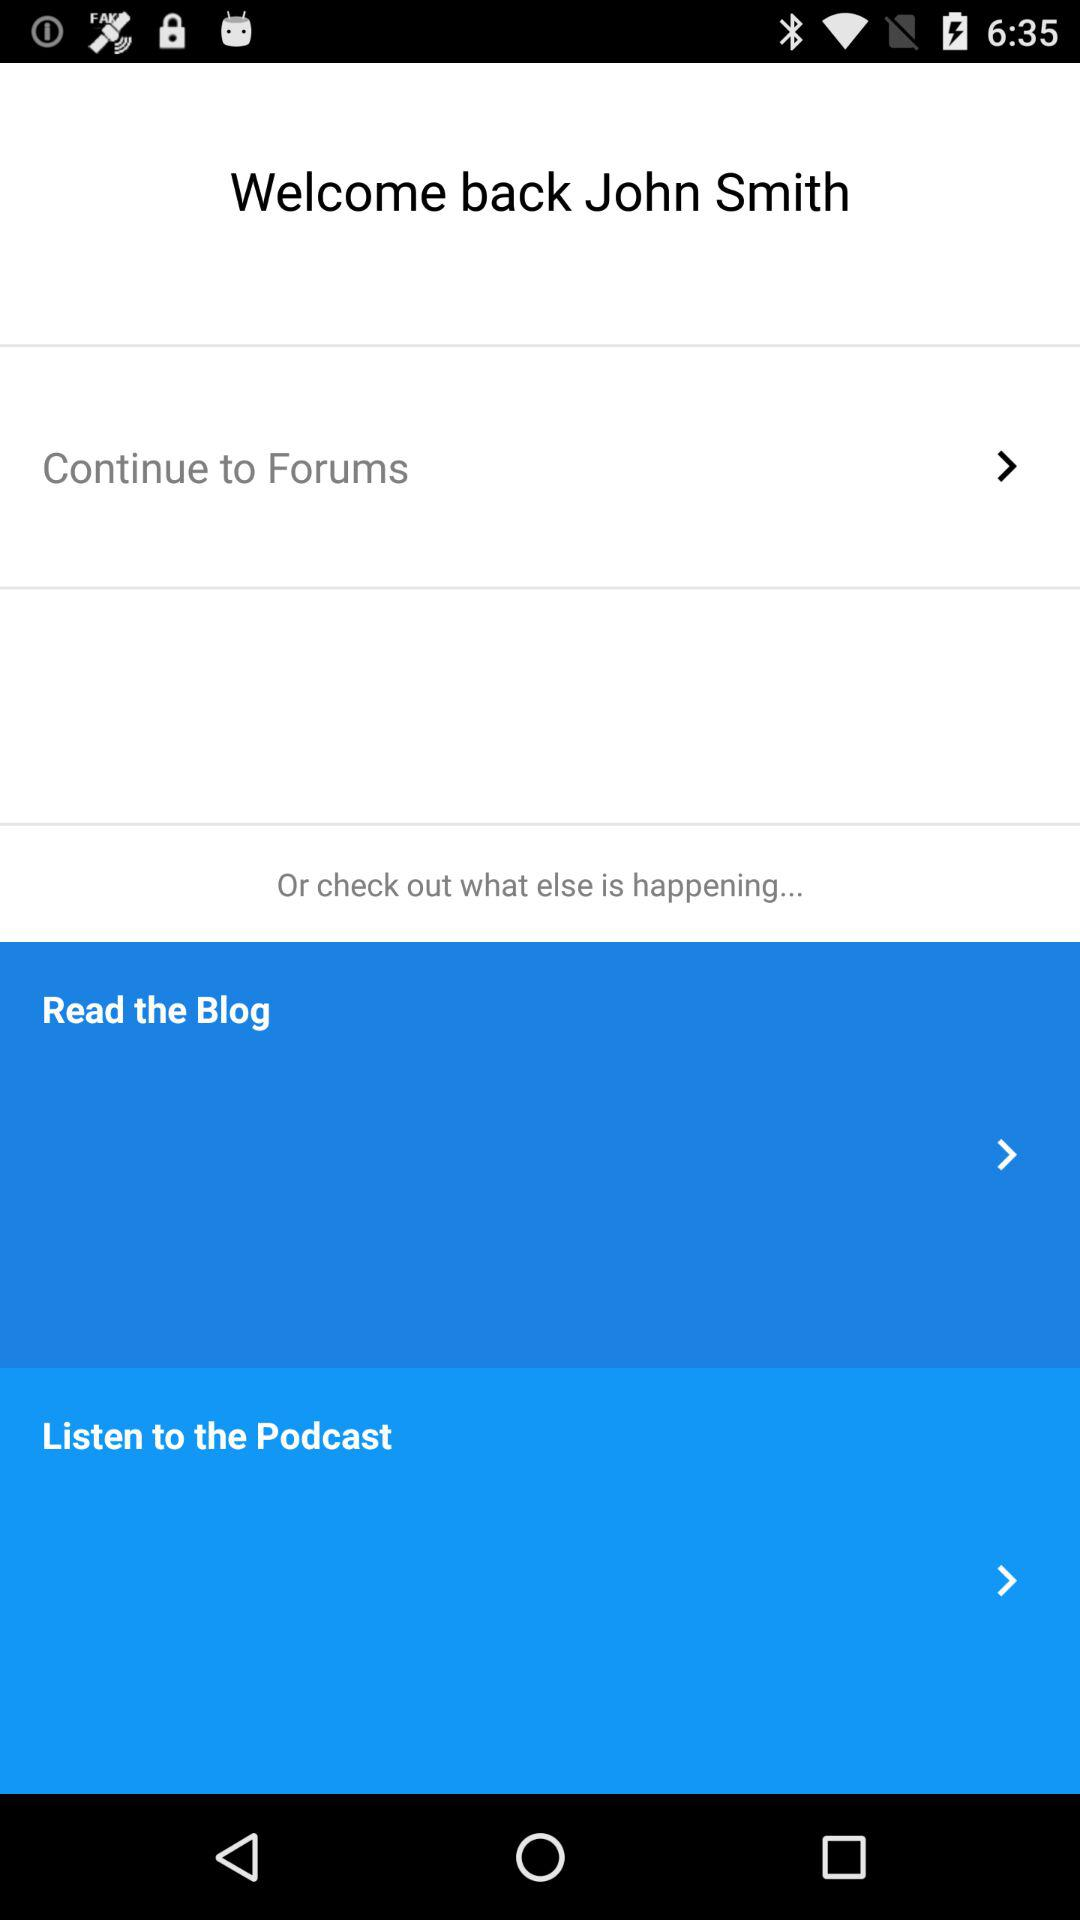What is the user name? The user name is John Smith. 